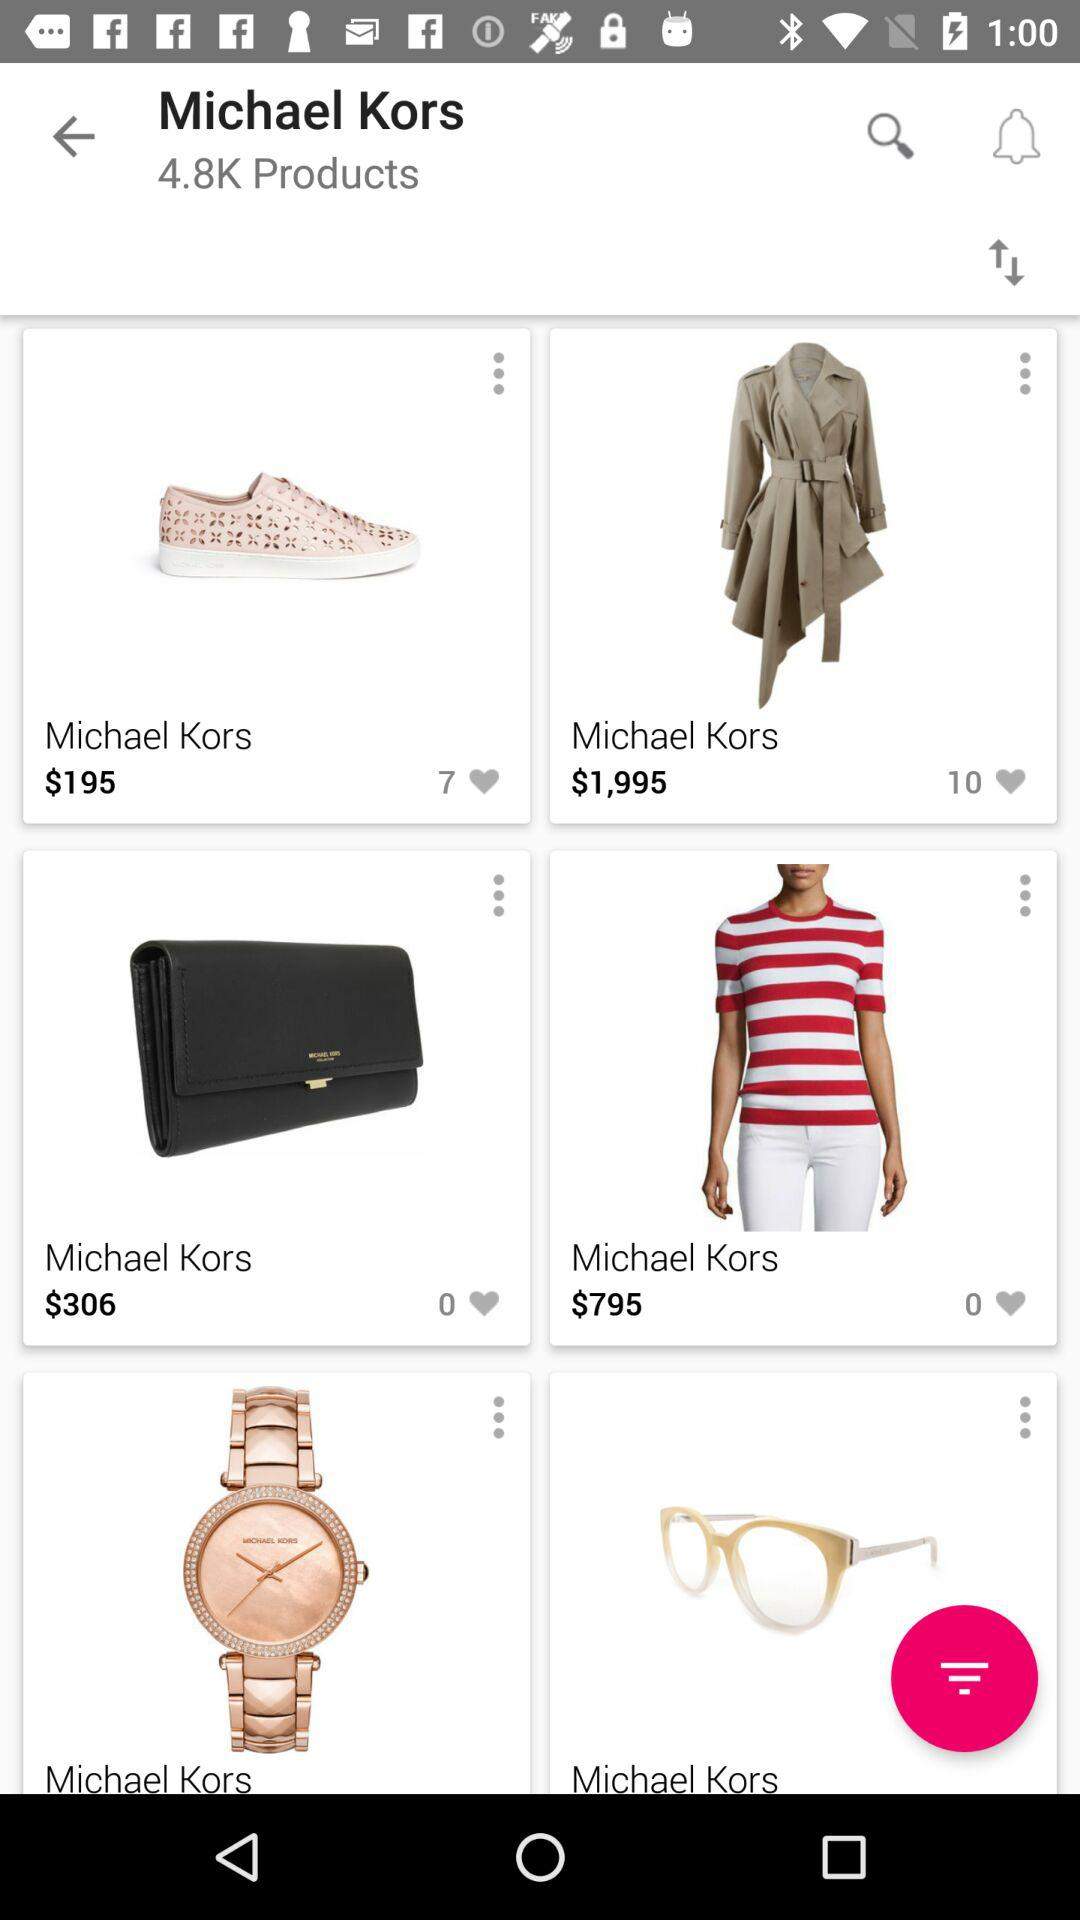What is the price of tshirt?
When the provided information is insufficient, respond with <no answer>. <no answer> 